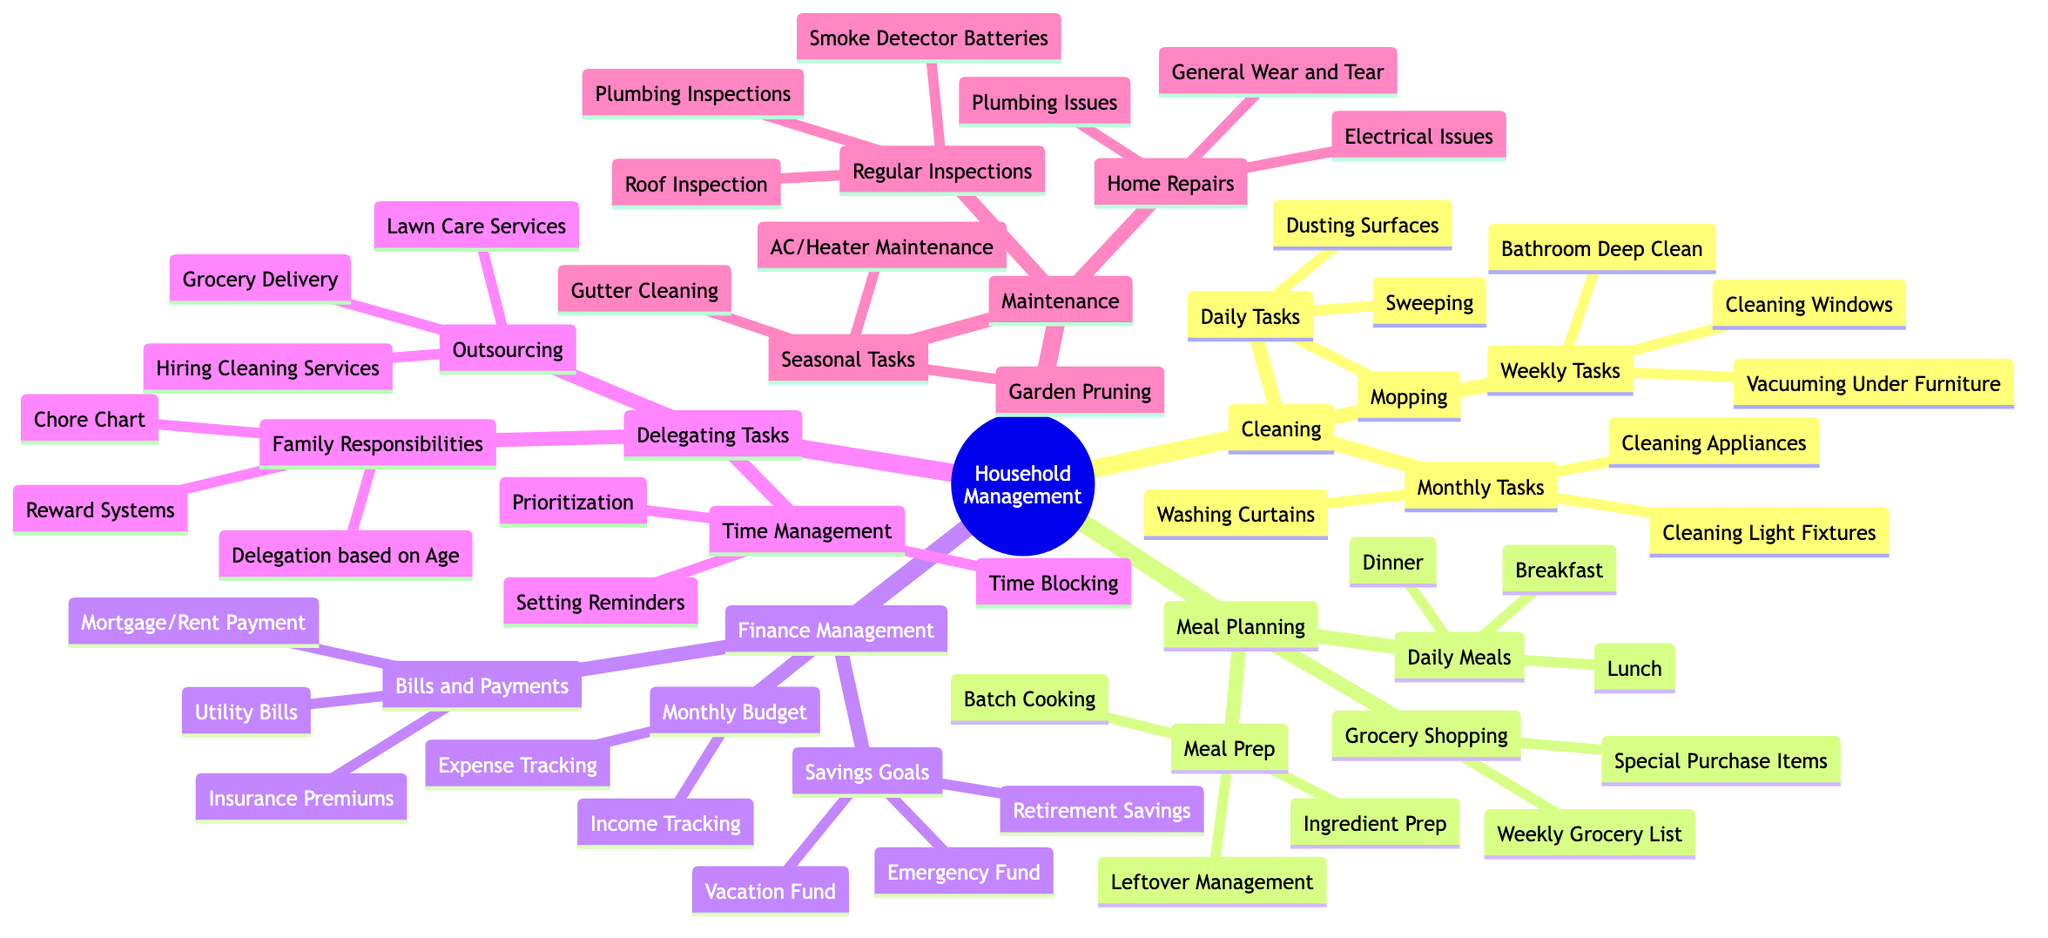What are the daily tasks in cleaning? The diagram indicates three daily tasks listed under the "Cleaning" section, which are "Sweeping," "Mopping," and "Dusting Surfaces."
Answer: Sweeping, Mopping, Dusting Surfaces How many monthly tasks are listed under cleaning? The diagram shows three monthly tasks in the "Cleaning" section, specifically "Cleaning Light Fixtures," "Washing Curtains," and "Cleaning Appliances."
Answer: 3 What is one way to delegate tasks in the household? The "Delegating Tasks" section includes "Chore Chart," which provides a method for dividing responsibilities among family members.
Answer: Chore Chart Which section includes "Batch Cooking"? The "Meal Prep" subsection under "Meal Planning" contains "Batch Cooking" as one of its key elements for organizing meal preparation.
Answer: Meal Planning How many items are listed under "Savings Goals"? The "Savings Goals" subsection has three listed items: "Emergency Fund," "Vacation Fund," and "Retirement Savings." This can be verified by counting each item under that category.
Answer: 3 What is the relationship between "Utility Bills" and "Finance Management"? "Utility Bills" belongs to the "Bills and Payments" subsection of "Finance Management," showing that it is a type of payment tracked within financial management activities.
Answer: Bills and Payments Which task must be performed seasonally? The "Seasonal Tasks" subsection in "Maintenance" includes "Gutter Cleaning," which is explicitly mentioned as a task that should occur with the seasons.
Answer: Gutter Cleaning How many tasks are identified in "Meal Planning"? In "Meal Planning," there are three distinct subcategories: "Daily Meals," "Grocery Shopping," and "Meal Prep," with several tasks under each, leading to a total count of eleven tasks overall.
Answer: 11 What is one of the family responsibilities for delegating tasks? The "Delegating Tasks" section proposes "Delegation based on Age" as one strategy to assign household tasks according to each family member's age and capability.
Answer: Delegation based on Age 